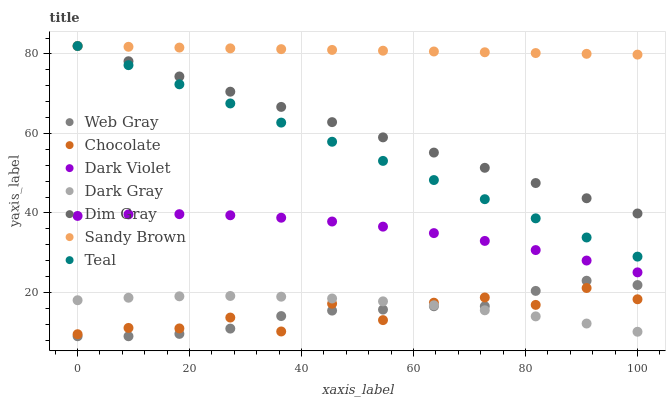Does Chocolate have the minimum area under the curve?
Answer yes or no. Yes. Does Sandy Brown have the maximum area under the curve?
Answer yes or no. Yes. Does Dark Violet have the minimum area under the curve?
Answer yes or no. No. Does Dark Violet have the maximum area under the curve?
Answer yes or no. No. Is Sandy Brown the smoothest?
Answer yes or no. Yes. Is Chocolate the roughest?
Answer yes or no. Yes. Is Dark Violet the smoothest?
Answer yes or no. No. Is Dark Violet the roughest?
Answer yes or no. No. Does Web Gray have the lowest value?
Answer yes or no. Yes. Does Dark Violet have the lowest value?
Answer yes or no. No. Does Sandy Brown have the highest value?
Answer yes or no. Yes. Does Dark Violet have the highest value?
Answer yes or no. No. Is Dark Violet less than Sandy Brown?
Answer yes or no. Yes. Is Dim Gray greater than Dark Gray?
Answer yes or no. Yes. Does Sandy Brown intersect Dim Gray?
Answer yes or no. Yes. Is Sandy Brown less than Dim Gray?
Answer yes or no. No. Is Sandy Brown greater than Dim Gray?
Answer yes or no. No. Does Dark Violet intersect Sandy Brown?
Answer yes or no. No. 